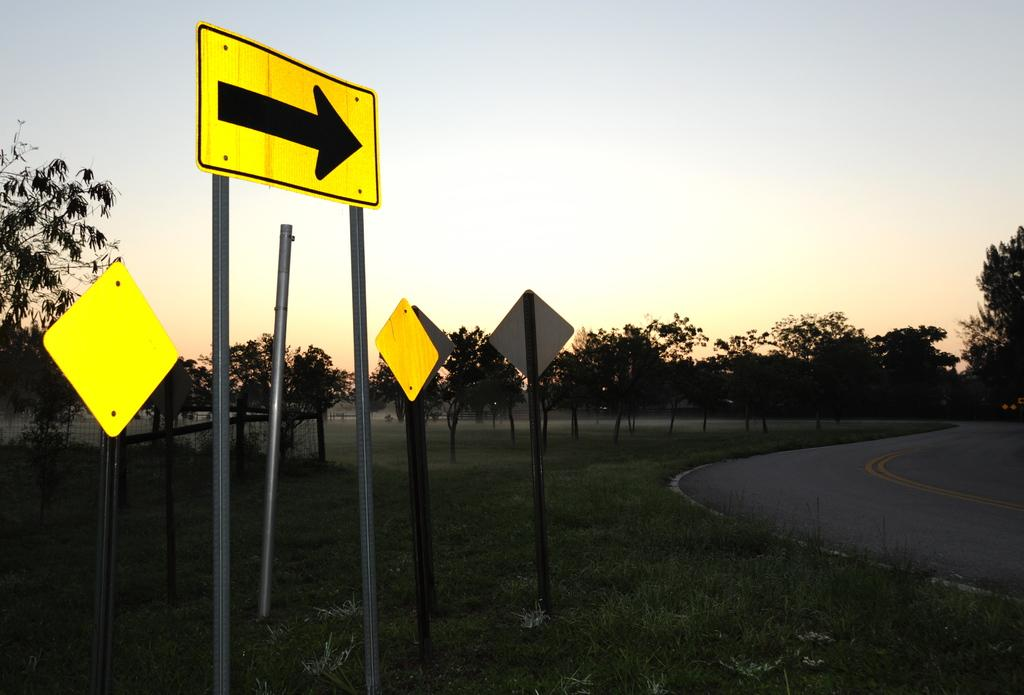What can be found on the grass in the image? There are sign boards on the surface of the grass. What type of pathway is present in the image? There is a road in the image. What type of vegetation is visible in the image? There are trees in the image. What is visible in the background of the image? The sky is visible in the image. What type of hope can be seen growing on the trees in the image? There is no hope growing on the trees in the image; it is a visual representation of a physical scene. What is the temperature like in the image? The image does not provide information about the temperature or heat; it only shows a visual scene. 